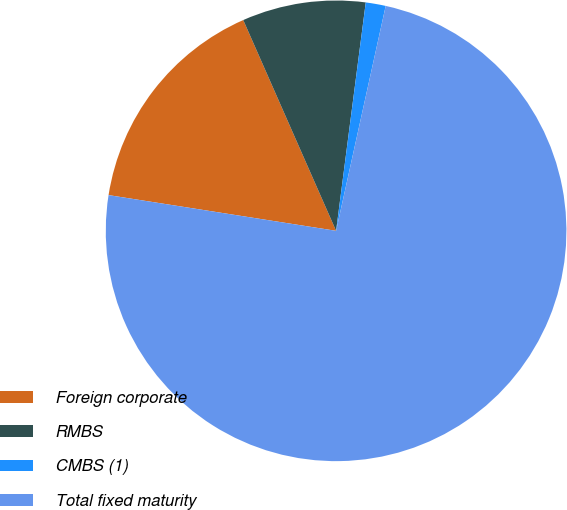<chart> <loc_0><loc_0><loc_500><loc_500><pie_chart><fcel>Foreign corporate<fcel>RMBS<fcel>CMBS (1)<fcel>Total fixed maturity<nl><fcel>15.92%<fcel>8.66%<fcel>1.4%<fcel>74.03%<nl></chart> 